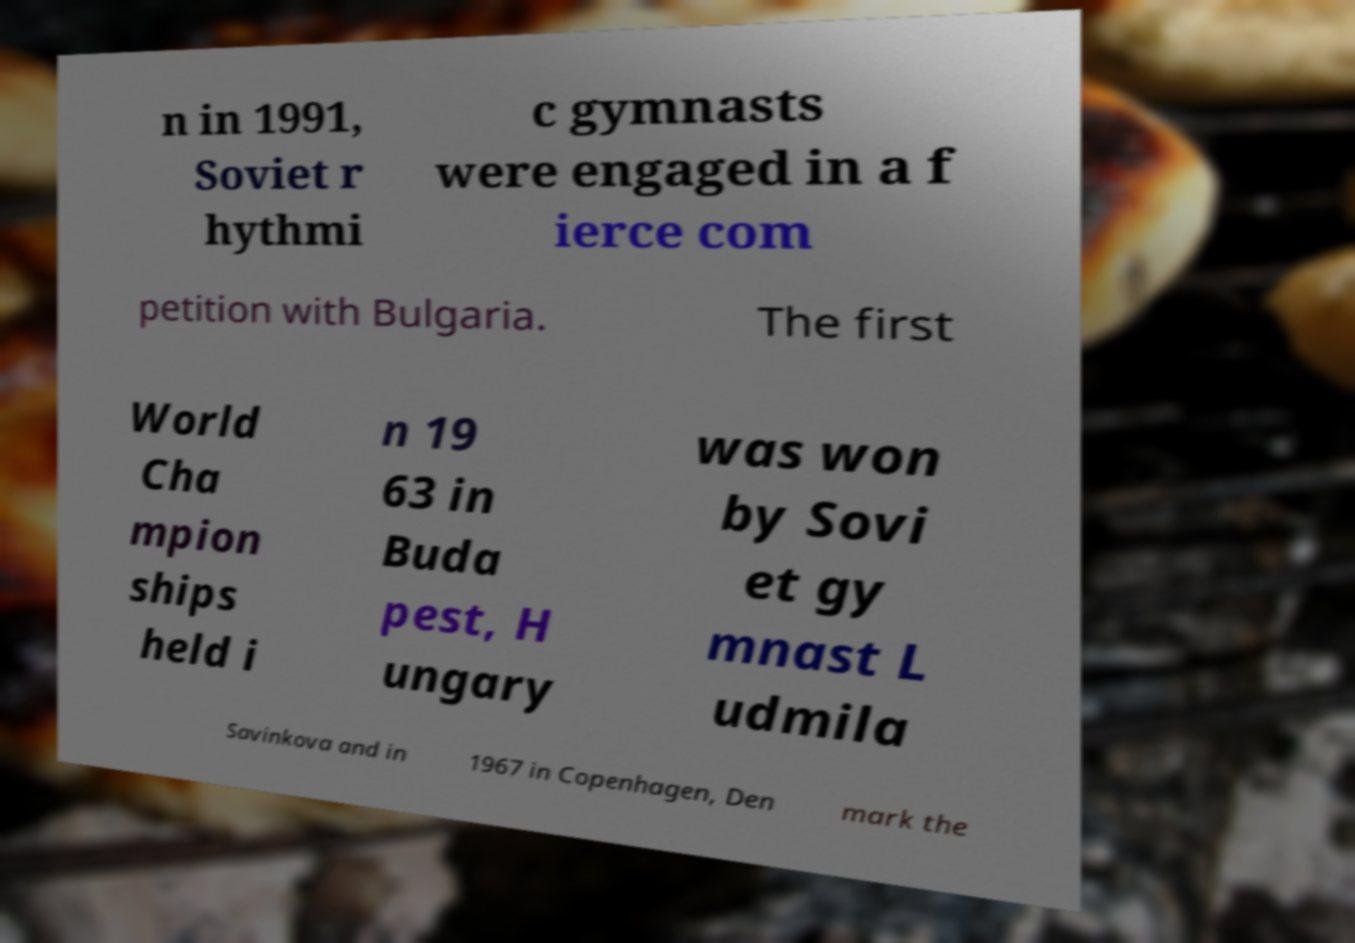What messages or text are displayed in this image? I need them in a readable, typed format. n in 1991, Soviet r hythmi c gymnasts were engaged in a f ierce com petition with Bulgaria. The first World Cha mpion ships held i n 19 63 in Buda pest, H ungary was won by Sovi et gy mnast L udmila Savinkova and in 1967 in Copenhagen, Den mark the 